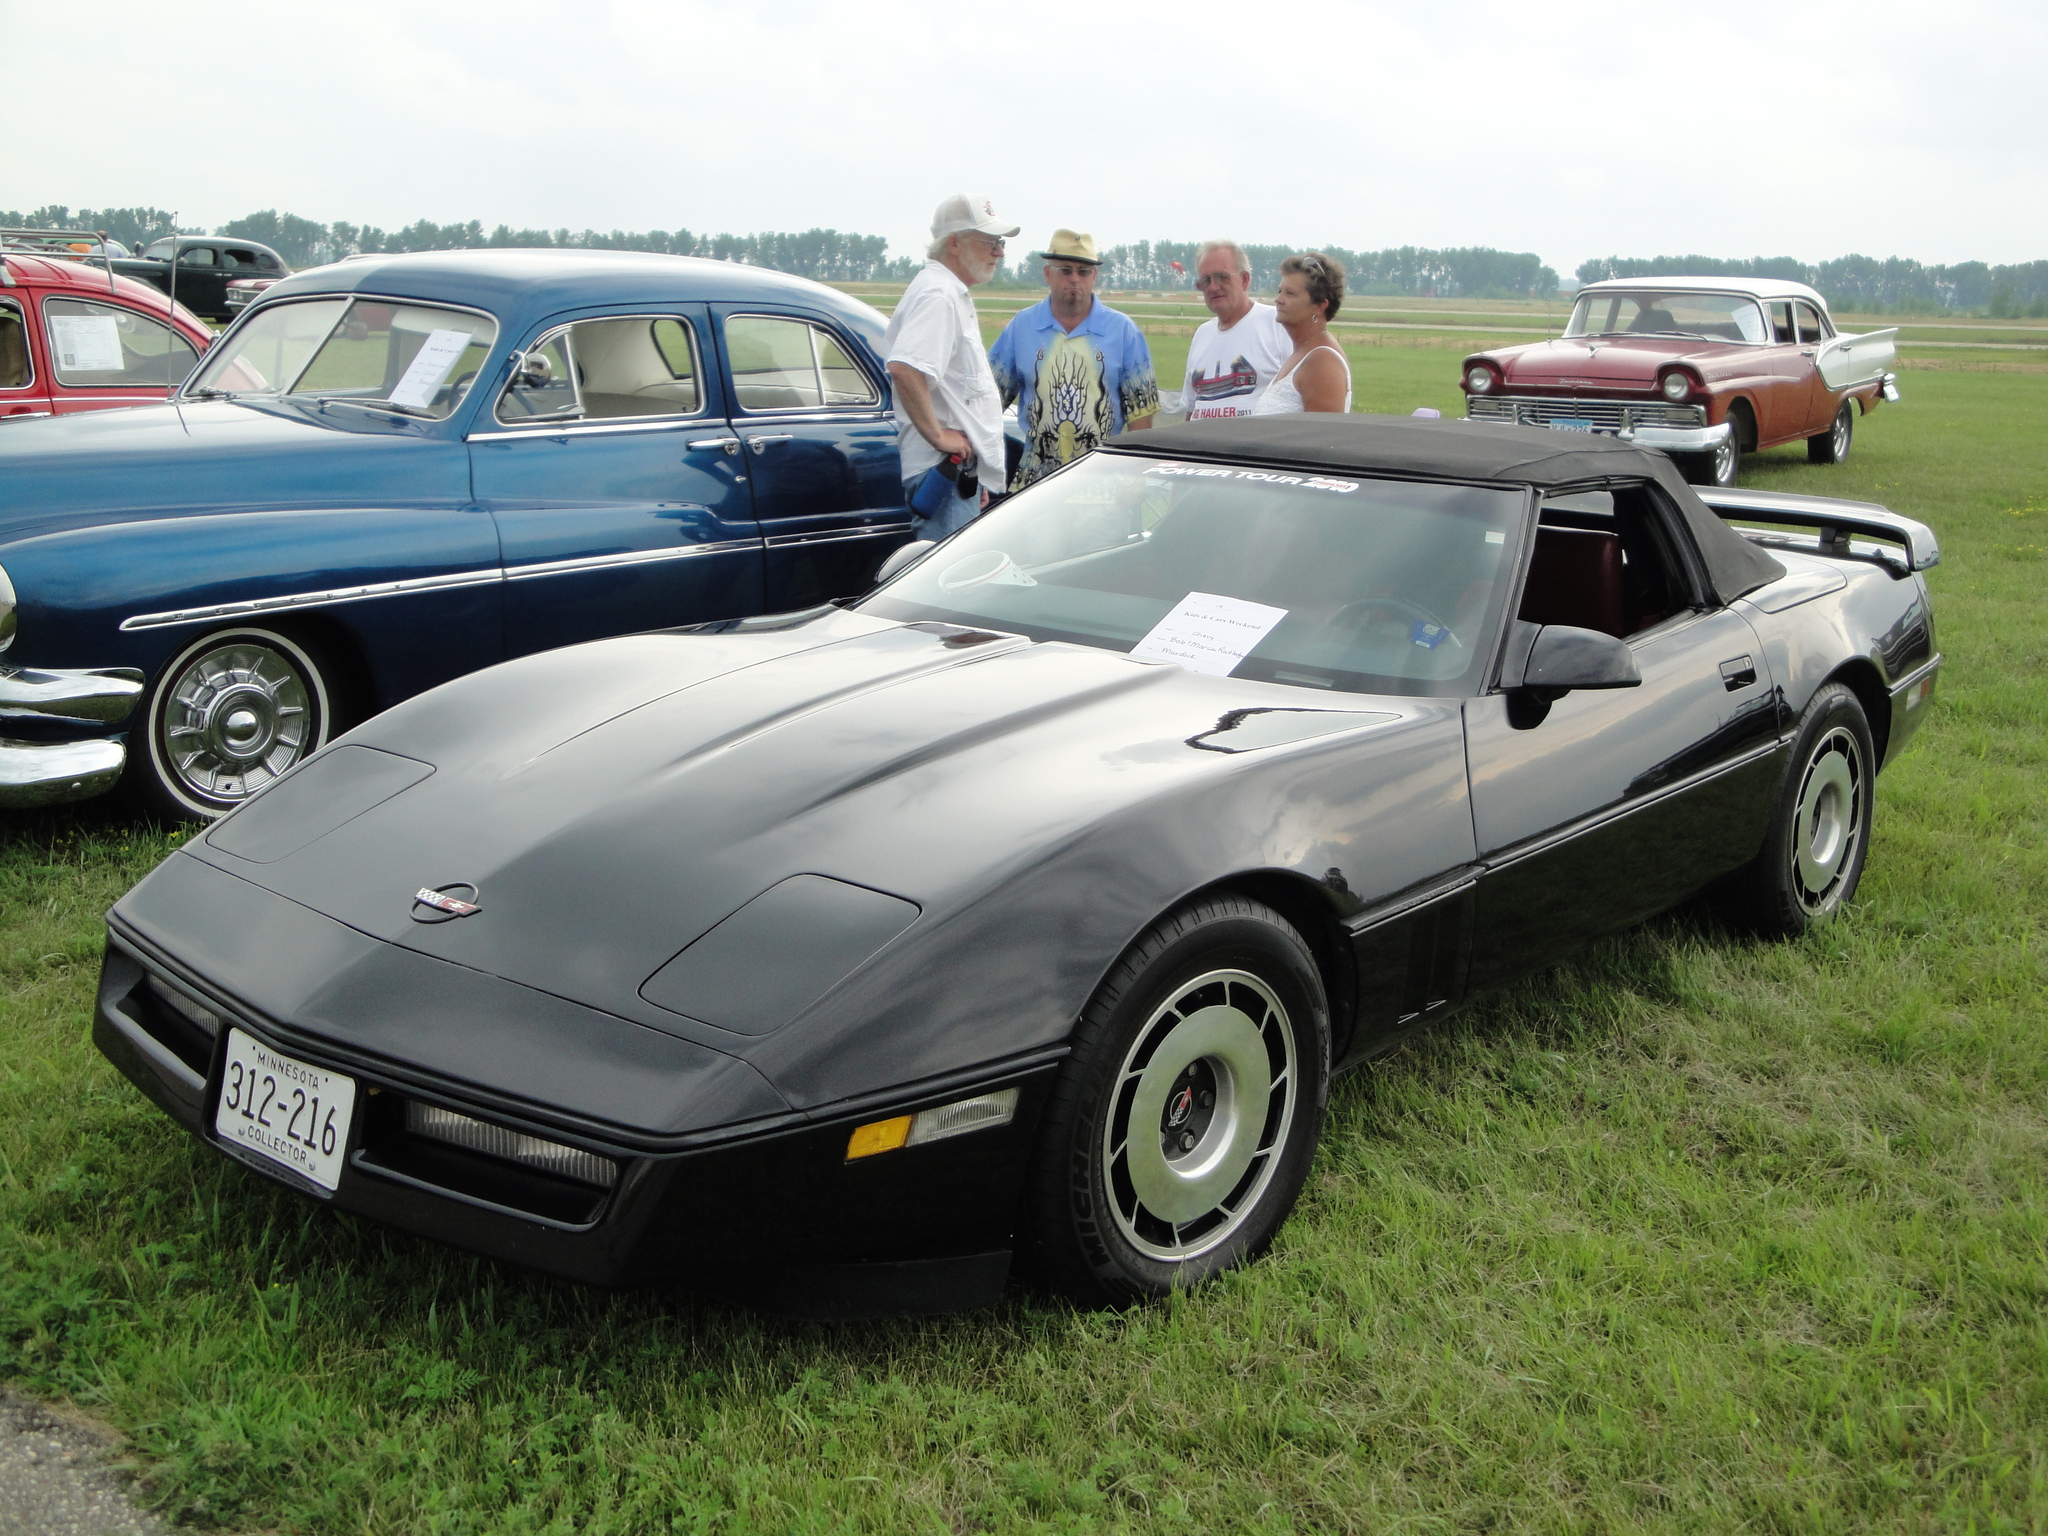Could you give a brief overview of what you see in this image? There are vehicles in different colors and there are persons on the ground, on which there is grass. In the background, there are trees and there are clouds in the sky. 